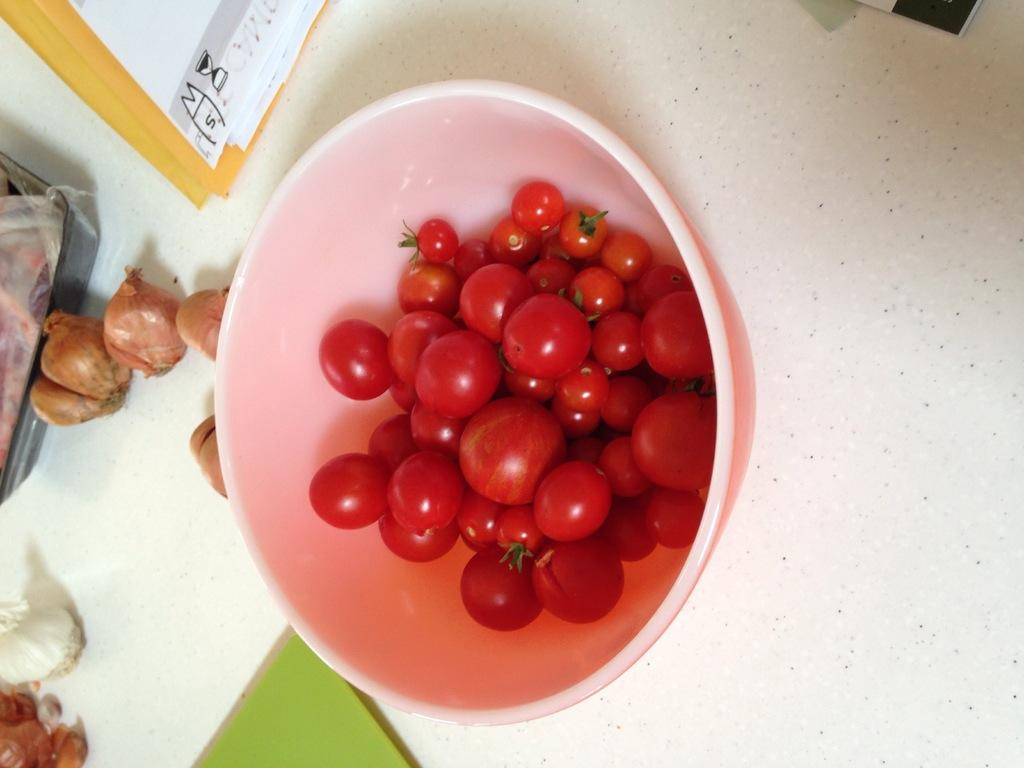What is in the bowl that is visible in the image? The bowl contains tomatoes. What else can be seen in the image besides the bowl? There is an object in the image. What is on the object in the image? The object has onions and other things on it. How many books are stacked on the nose in the image? There is no nose or books present in the image. 